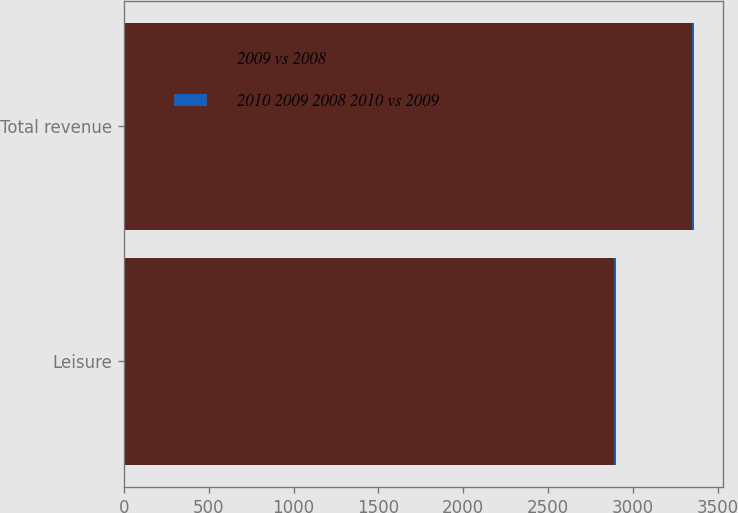Convert chart. <chart><loc_0><loc_0><loc_500><loc_500><stacked_bar_chart><ecel><fcel>Leisure<fcel>Total revenue<nl><fcel>2009 vs 2008<fcel>2891<fcel>3348<nl><fcel>2010 2009 2008 2010 vs 2009<fcel>10<fcel>13<nl></chart> 